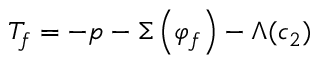<formula> <loc_0><loc_0><loc_500><loc_500>T _ { f } = - p - \Sigma \left ( \varphi _ { f } \right ) - \Lambda ( c _ { 2 } )</formula> 